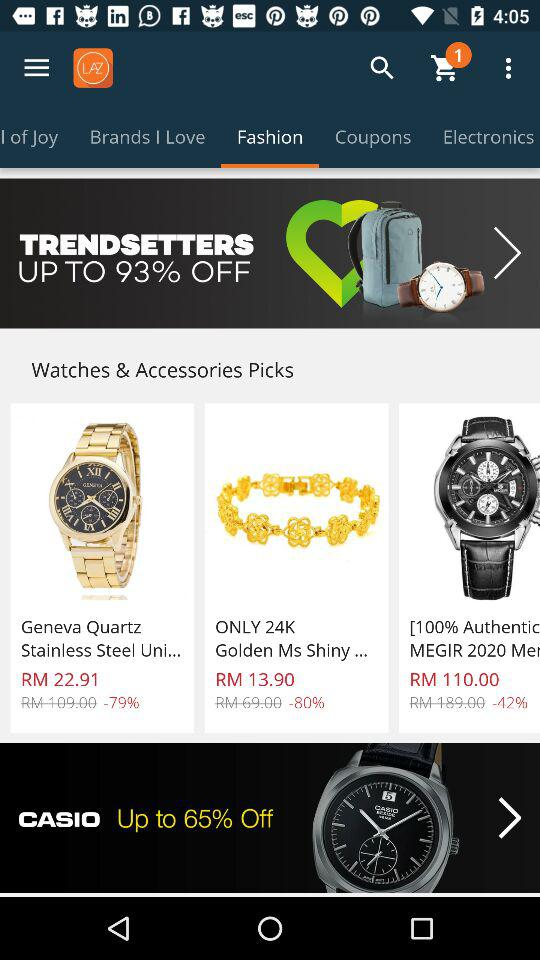How many discounts are displayed on the screen?
Answer the question using a single word or phrase. 3 